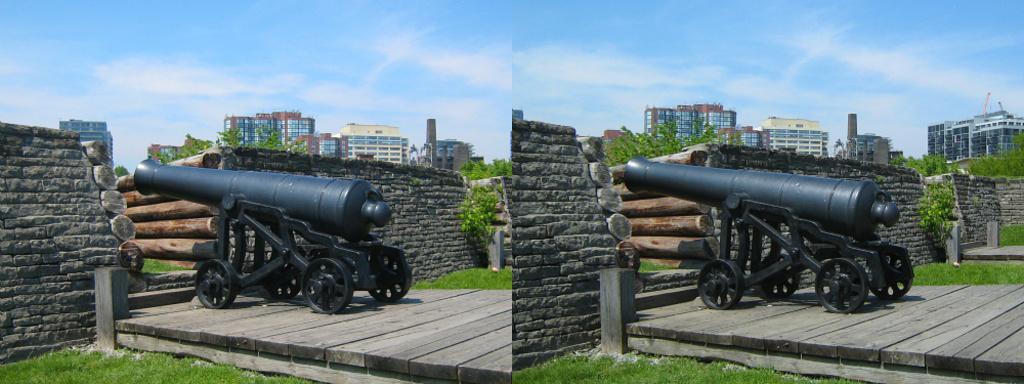Could you give a brief overview of what you see in this image? In this image we can see collage picture of rifle, wood, buildings, wall, trees and sky. 